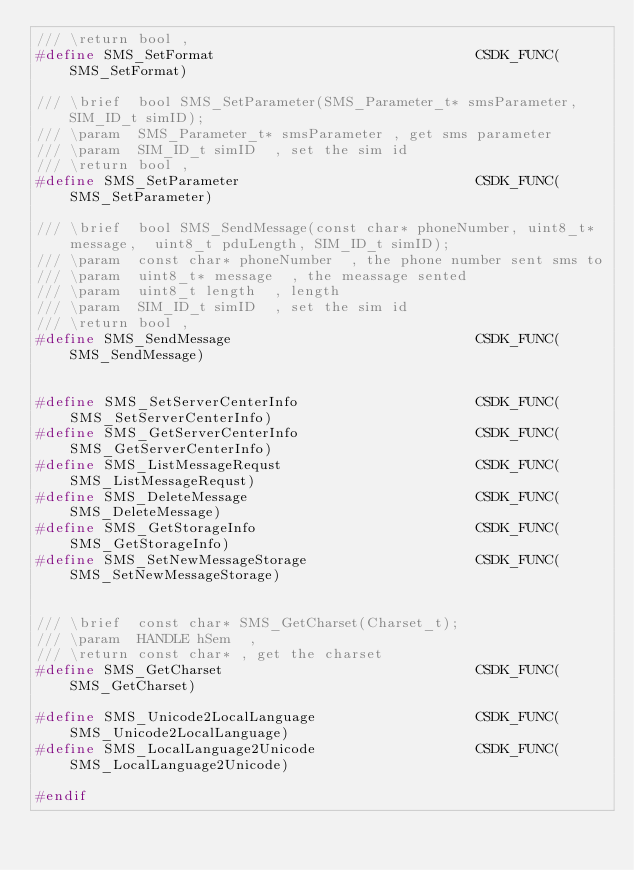<code> <loc_0><loc_0><loc_500><loc_500><_C_>/// \return bool , 
#define SMS_SetFormat                               CSDK_FUNC(SMS_SetFormat)

/// \brief  bool SMS_SetParameter(SMS_Parameter_t* smsParameter,SIM_ID_t simID);
/// \param  SMS_Parameter_t* smsParameter , get sms parameter
/// \param  SIM_ID_t simID  , set the sim id
/// \return bool , 
#define SMS_SetParameter                            CSDK_FUNC(SMS_SetParameter)

/// \brief  bool SMS_SendMessage(const char* phoneNumber, uint8_t* message,  uint8_t pduLength, SIM_ID_t simID);
/// \param  const char* phoneNumber  , the phone number sent sms to 
/// \param  uint8_t* message  , the meassage sented 
/// \param  uint8_t length  , length
/// \param  SIM_ID_t simID  , set the sim id
/// \return bool , 
#define SMS_SendMessage                             CSDK_FUNC(SMS_SendMessage)


#define SMS_SetServerCenterInfo                     CSDK_FUNC(SMS_SetServerCenterInfo)
#define SMS_GetServerCenterInfo                     CSDK_FUNC(SMS_GetServerCenterInfo)
#define SMS_ListMessageRequst                       CSDK_FUNC(SMS_ListMessageRequst)
#define SMS_DeleteMessage                           CSDK_FUNC(SMS_DeleteMessage)
#define SMS_GetStorageInfo                          CSDK_FUNC(SMS_GetStorageInfo)
#define SMS_SetNewMessageStorage                    CSDK_FUNC(SMS_SetNewMessageStorage)


/// \brief  const char* SMS_GetCharset(Charset_t);
/// \param  HANDLE hSem  , 
/// \return const char* , get the charset
#define SMS_GetCharset                              CSDK_FUNC(SMS_GetCharset)

#define SMS_Unicode2LocalLanguage                   CSDK_FUNC(SMS_Unicode2LocalLanguage)
#define SMS_LocalLanguage2Unicode                   CSDK_FUNC(SMS_LocalLanguage2Unicode)

#endif

</code> 